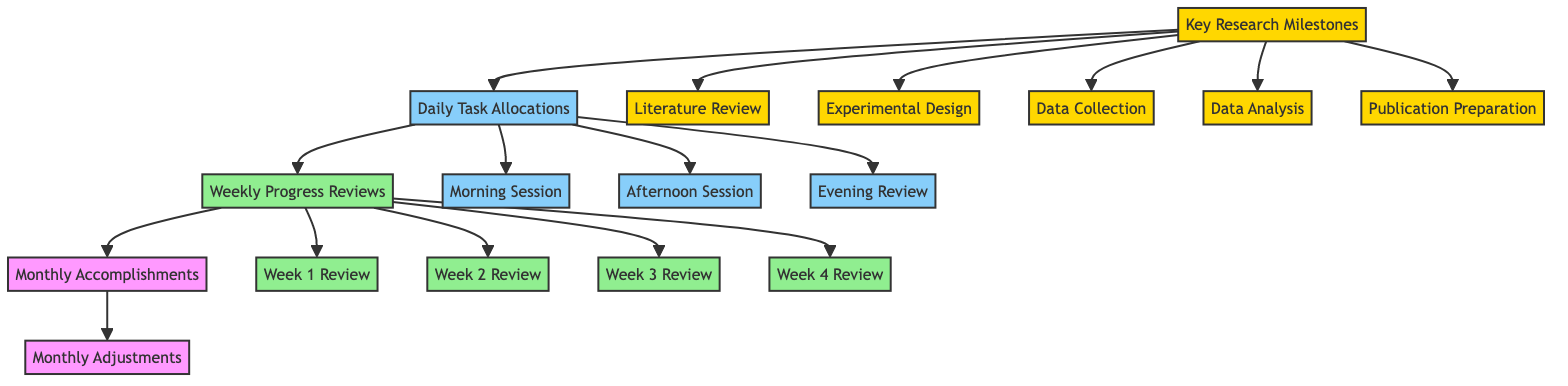What's the first step in the process? The process begins with the "Key Research Milestones" node, which identifies the major objectives and goals for the research.
Answer: Key Research Milestones How many weekly reviews are there? There are four weekly reviews specified: Week 1 Review, Week 2 Review, Week 3 Review, and Week 4 Review.
Answer: Four What is the last step in the flowchart? The last step in the flowchart is "Monthly Adjustments," which involves reviewing accomplished milestones and adjusting the research plan.
Answer: Monthly Adjustments What follows the "Daily Task Allocations"? The "Weekly Progress Reviews" node follows "Daily Task Allocations," indicating that after daily tasks are assigned, progress reviews occur weekly.
Answer: Weekly Progress Reviews What type of session is allocated for practical lab work? The "Afternoon Session" is designated for practical lab work, experiments, or collaborative activities.
Answer: Afternoon Session How many main categories are there under "Key Research Milestones"? There are five main categories under "Key Research Milestones," focusing on different aspects of the research process.
Answer: Five What is assessed during the "Week 3 Review"? The "Week 3 Review" evaluates the accomplishments and ongoing tasks of the third week of the month.
Answer: Accomplishments and ongoing tasks Which component summarizes the significant achievements of the month? The "Monthly Accomplishments" component summarizes the significant achievements and tasks completed during the month.
Answer: Monthly Accomplishments What sessions are followed in the daily task allocations? The daily tasks include three sessions: Morning Session, Afternoon Session, and Evening Review, capturing various aspects of daily research activities.
Answer: Morning Session, Afternoon Session, Evening Review 